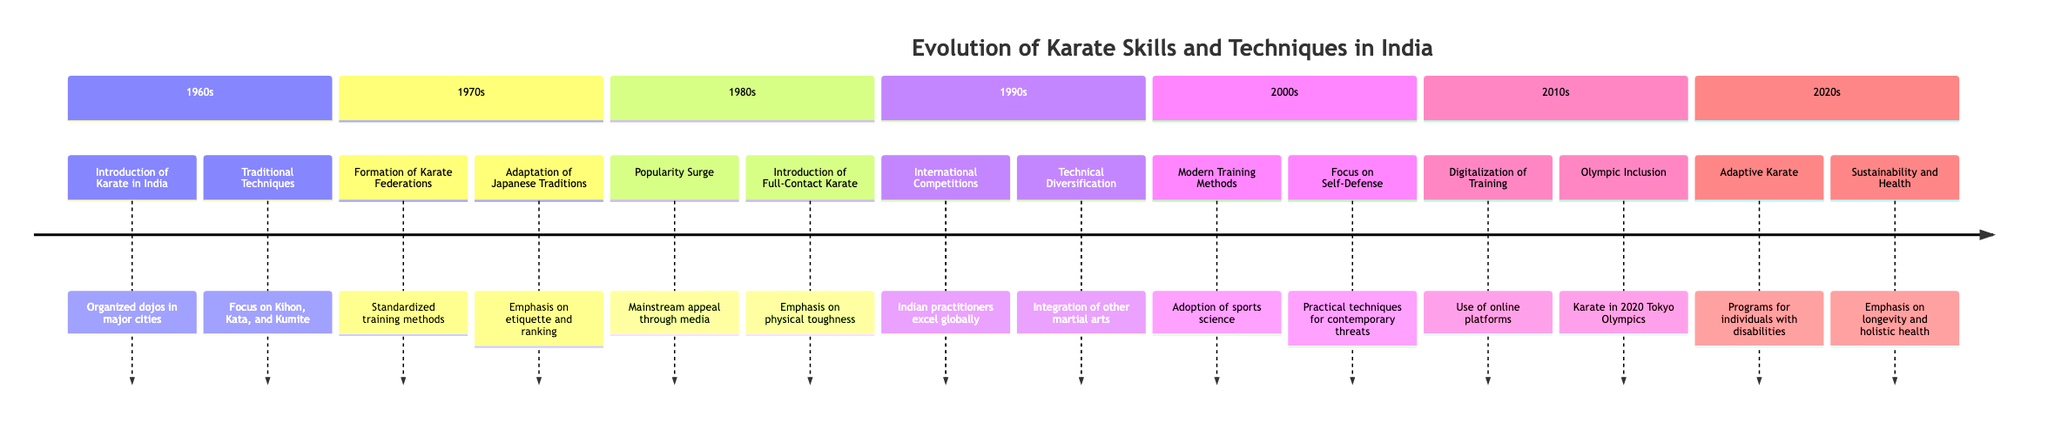What decade was the introduction of Karate in India? The timeline indicates that Karate was introduced in India during the 1960s. This is the decade associated with the first entry of Karate into the Indian martial arts scene.
Answer: 1960s What does the 1970s section highlight about Karate organizations? The 1970s section mentions the formation of karate federations, specifically noting the establishment of the All India Karate-Do Federation as a key development that standardized training methods.
Answer: Formation of Karate Federations What was a significant change in the 1980s for Karate? The 1980s introduced full-contact Karate styles such as Kyokushin, which indicates a shift toward more physically demanding and realistic training practices.
Answer: Introduction of Full-Contact Karate In which decade did Indian Karate practitioners first excel in international competitions? The timeline specifies that Indian Karate practitioners began to participate and excel in international tournaments during the 1990s, marking a significant achievement for Indian Karate on a global stage.
Answer: 1990s How did Karate training evolve in the 2000s? The 2000s saw the adoption of modern training methods that incorporated sports science, which improved performance through specialized conditioning and fitness practices.
Answer: Modern Training Methods What new trend emerged in the 2010s related to the accessibility of training? The 2010s section presents the digitalization of training as a key trend, highlighting the use of online platforms and digital tools to enhance access to Karate training and instruction.
Answer: Digitalization of Training Which decade marked the inclusion of Karate in the Olympics? The timeline states that the inclusion of Karate as a sport in the 2020 Tokyo Olympics occurred in the 2010s, elevating the status and formal training standards of the discipline.
Answer: Olympic Inclusion What does the 2020s section focus on regarding sustainability in Karate? The timeline for the 2020s emphasizes sustainability and health, indicating a growing concern for practice that promotes physical longevity and holistic health within martial arts training environments.
Answer: Sustainability and Health How many main elements are featured in the 1980s section? The 1980s section has two main elements: the surge in popularity of Karate and the introduction of full-contact Karate styles. Hence, the total count of these elements is determined to be two.
Answer: 2 